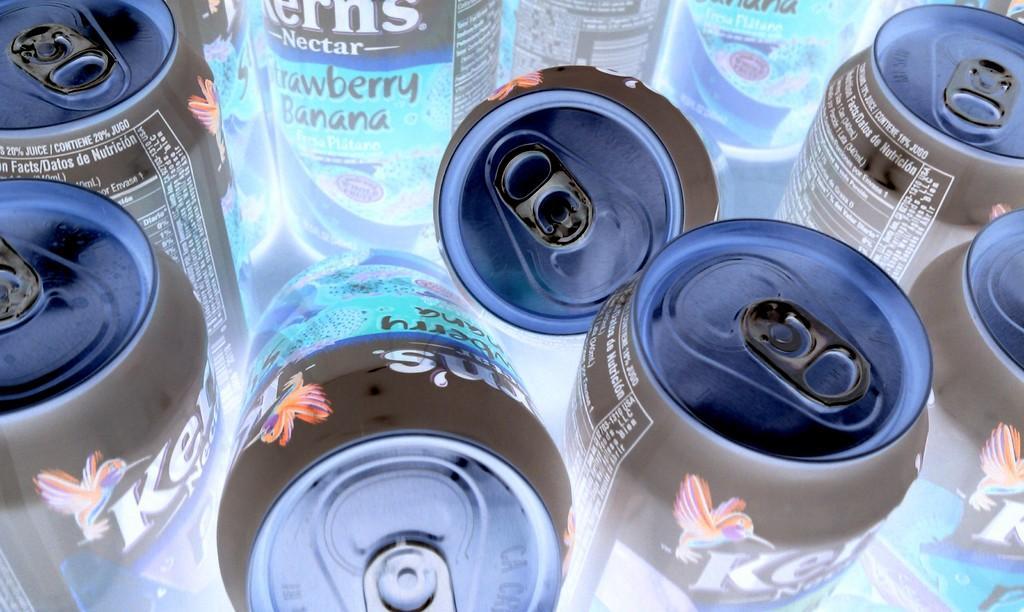Could you give a brief overview of what you see in this image? In this picture we can see tins. 